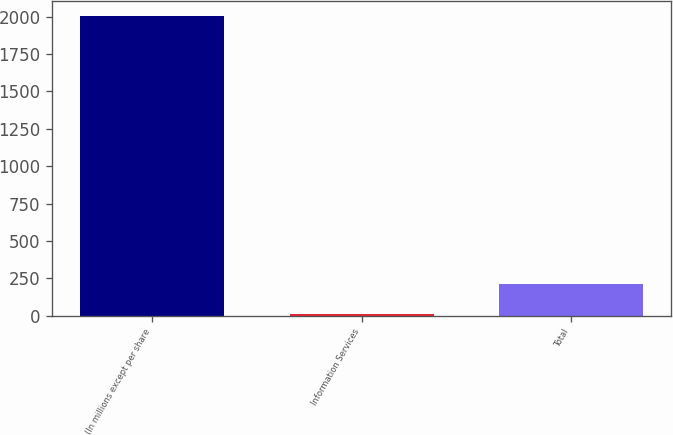Convert chart. <chart><loc_0><loc_0><loc_500><loc_500><bar_chart><fcel>(In millions except per share<fcel>Information Services<fcel>Total<nl><fcel>2003<fcel>12.7<fcel>211.73<nl></chart> 